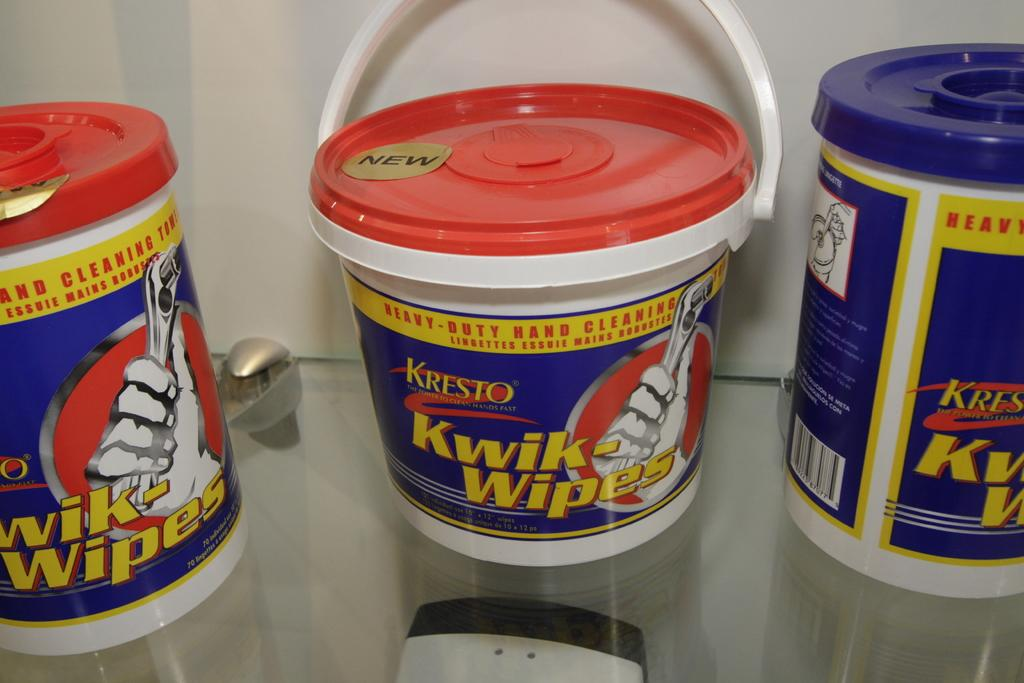<image>
Relay a brief, clear account of the picture shown. Three red and blue containers of Kresto Kwik-Wipes are on the shelf. 